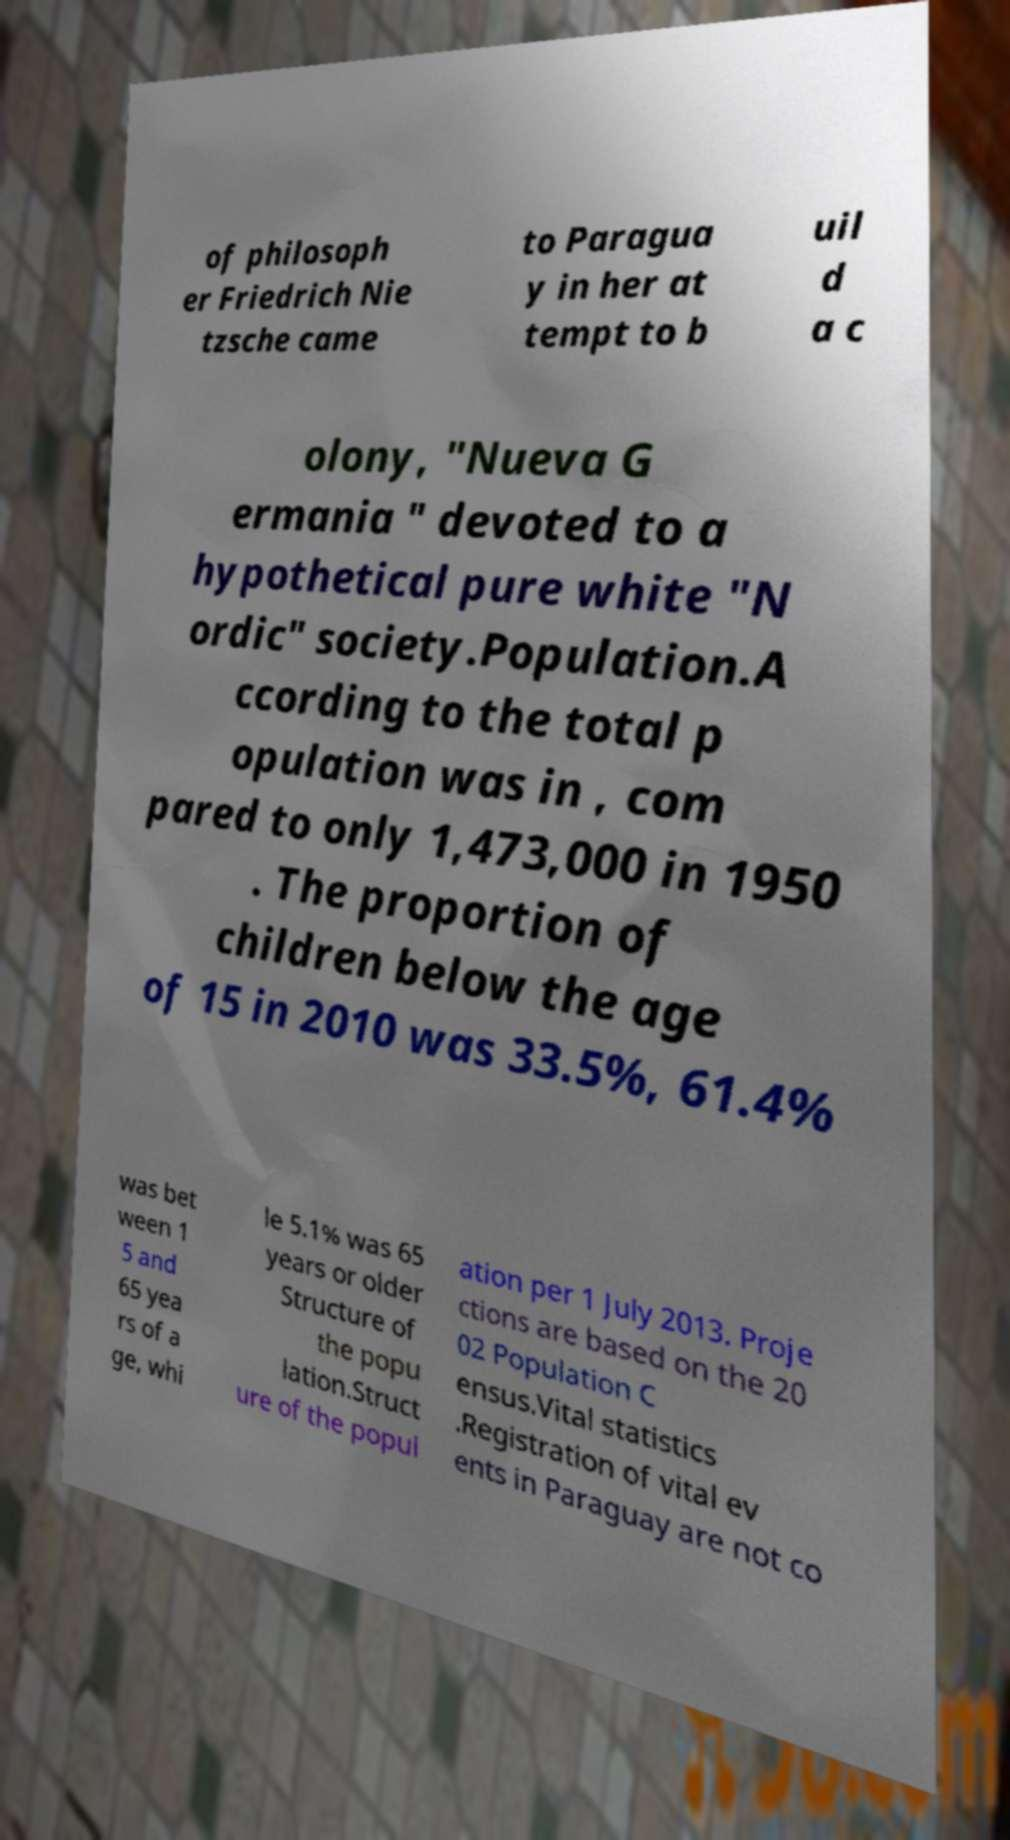Can you read and provide the text displayed in the image?This photo seems to have some interesting text. Can you extract and type it out for me? of philosoph er Friedrich Nie tzsche came to Paragua y in her at tempt to b uil d a c olony, "Nueva G ermania " devoted to a hypothetical pure white "N ordic" society.Population.A ccording to the total p opulation was in , com pared to only 1,473,000 in 1950 . The proportion of children below the age of 15 in 2010 was 33.5%, 61.4% was bet ween 1 5 and 65 yea rs of a ge, whi le 5.1% was 65 years or older Structure of the popu lation.Struct ure of the popul ation per 1 July 2013. Proje ctions are based on the 20 02 Population C ensus.Vital statistics .Registration of vital ev ents in Paraguay are not co 